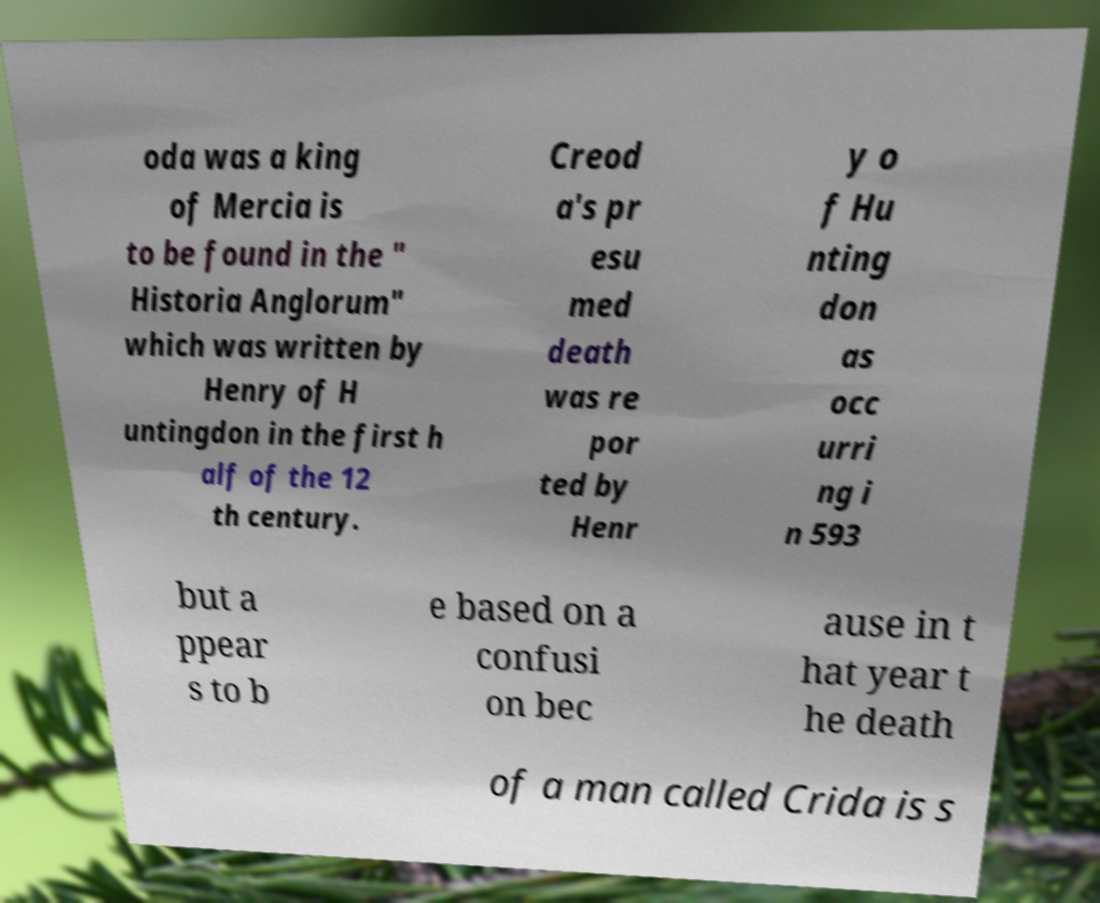Can you read and provide the text displayed in the image?This photo seems to have some interesting text. Can you extract and type it out for me? oda was a king of Mercia is to be found in the " Historia Anglorum" which was written by Henry of H untingdon in the first h alf of the 12 th century. Creod a's pr esu med death was re por ted by Henr y o f Hu nting don as occ urri ng i n 593 but a ppear s to b e based on a confusi on bec ause in t hat year t he death of a man called Crida is s 